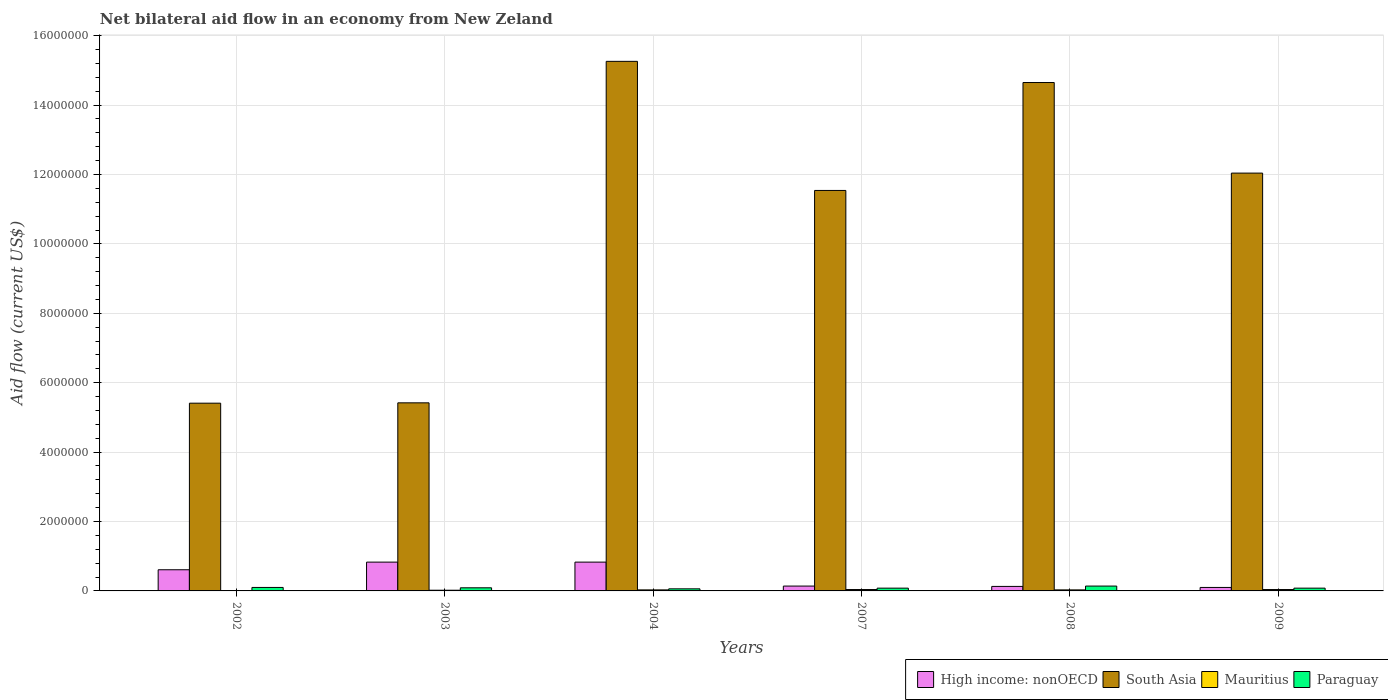How many different coloured bars are there?
Provide a succinct answer. 4. Are the number of bars per tick equal to the number of legend labels?
Offer a terse response. Yes. How many bars are there on the 5th tick from the right?
Keep it short and to the point. 4. What is the label of the 4th group of bars from the left?
Your answer should be very brief. 2007. In how many cases, is the number of bars for a given year not equal to the number of legend labels?
Offer a terse response. 0. In which year was the net bilateral aid flow in Paraguay minimum?
Give a very brief answer. 2004. What is the total net bilateral aid flow in South Asia in the graph?
Offer a terse response. 6.43e+07. What is the difference between the net bilateral aid flow in South Asia in 2002 and that in 2008?
Your answer should be compact. -9.24e+06. What is the average net bilateral aid flow in Mauritius per year?
Provide a succinct answer. 2.83e+04. In the year 2007, what is the difference between the net bilateral aid flow in High income: nonOECD and net bilateral aid flow in South Asia?
Make the answer very short. -1.14e+07. In how many years, is the net bilateral aid flow in Mauritius greater than 14400000 US$?
Your answer should be very brief. 0. What is the ratio of the net bilateral aid flow in South Asia in 2003 to that in 2004?
Your answer should be compact. 0.36. Is the net bilateral aid flow in South Asia in 2002 less than that in 2004?
Provide a succinct answer. Yes. What is the difference between the highest and the second highest net bilateral aid flow in High income: nonOECD?
Offer a very short reply. 0. What is the difference between the highest and the lowest net bilateral aid flow in South Asia?
Give a very brief answer. 9.85e+06. In how many years, is the net bilateral aid flow in South Asia greater than the average net bilateral aid flow in South Asia taken over all years?
Offer a terse response. 4. Is it the case that in every year, the sum of the net bilateral aid flow in South Asia and net bilateral aid flow in High income: nonOECD is greater than the sum of net bilateral aid flow in Paraguay and net bilateral aid flow in Mauritius?
Make the answer very short. No. What does the 2nd bar from the left in 2004 represents?
Provide a short and direct response. South Asia. What does the 3rd bar from the right in 2003 represents?
Make the answer very short. South Asia. How many bars are there?
Offer a terse response. 24. How many years are there in the graph?
Provide a short and direct response. 6. What is the difference between two consecutive major ticks on the Y-axis?
Provide a succinct answer. 2.00e+06. Where does the legend appear in the graph?
Your answer should be compact. Bottom right. How are the legend labels stacked?
Offer a very short reply. Horizontal. What is the title of the graph?
Provide a short and direct response. Net bilateral aid flow in an economy from New Zeland. What is the Aid flow (current US$) of High income: nonOECD in 2002?
Offer a very short reply. 6.10e+05. What is the Aid flow (current US$) of South Asia in 2002?
Your response must be concise. 5.41e+06. What is the Aid flow (current US$) of High income: nonOECD in 2003?
Your response must be concise. 8.30e+05. What is the Aid flow (current US$) in South Asia in 2003?
Ensure brevity in your answer.  5.42e+06. What is the Aid flow (current US$) of Paraguay in 2003?
Ensure brevity in your answer.  9.00e+04. What is the Aid flow (current US$) of High income: nonOECD in 2004?
Provide a short and direct response. 8.30e+05. What is the Aid flow (current US$) in South Asia in 2004?
Your answer should be compact. 1.53e+07. What is the Aid flow (current US$) of South Asia in 2007?
Ensure brevity in your answer.  1.15e+07. What is the Aid flow (current US$) in Mauritius in 2007?
Give a very brief answer. 4.00e+04. What is the Aid flow (current US$) of Paraguay in 2007?
Provide a short and direct response. 8.00e+04. What is the Aid flow (current US$) of South Asia in 2008?
Your answer should be compact. 1.46e+07. What is the Aid flow (current US$) of Paraguay in 2008?
Make the answer very short. 1.40e+05. What is the Aid flow (current US$) in South Asia in 2009?
Provide a succinct answer. 1.20e+07. Across all years, what is the maximum Aid flow (current US$) of High income: nonOECD?
Keep it short and to the point. 8.30e+05. Across all years, what is the maximum Aid flow (current US$) in South Asia?
Ensure brevity in your answer.  1.53e+07. Across all years, what is the maximum Aid flow (current US$) of Mauritius?
Your answer should be compact. 4.00e+04. Across all years, what is the maximum Aid flow (current US$) in Paraguay?
Give a very brief answer. 1.40e+05. Across all years, what is the minimum Aid flow (current US$) in High income: nonOECD?
Offer a terse response. 1.00e+05. Across all years, what is the minimum Aid flow (current US$) in South Asia?
Keep it short and to the point. 5.41e+06. What is the total Aid flow (current US$) in High income: nonOECD in the graph?
Make the answer very short. 2.64e+06. What is the total Aid flow (current US$) in South Asia in the graph?
Your response must be concise. 6.43e+07. What is the total Aid flow (current US$) in Paraguay in the graph?
Your answer should be very brief. 5.50e+05. What is the difference between the Aid flow (current US$) of High income: nonOECD in 2002 and that in 2004?
Offer a terse response. -2.20e+05. What is the difference between the Aid flow (current US$) of South Asia in 2002 and that in 2004?
Ensure brevity in your answer.  -9.85e+06. What is the difference between the Aid flow (current US$) of Paraguay in 2002 and that in 2004?
Offer a terse response. 4.00e+04. What is the difference between the Aid flow (current US$) in South Asia in 2002 and that in 2007?
Keep it short and to the point. -6.13e+06. What is the difference between the Aid flow (current US$) of Paraguay in 2002 and that in 2007?
Your answer should be very brief. 2.00e+04. What is the difference between the Aid flow (current US$) of High income: nonOECD in 2002 and that in 2008?
Your response must be concise. 4.80e+05. What is the difference between the Aid flow (current US$) in South Asia in 2002 and that in 2008?
Keep it short and to the point. -9.24e+06. What is the difference between the Aid flow (current US$) in Paraguay in 2002 and that in 2008?
Make the answer very short. -4.00e+04. What is the difference between the Aid flow (current US$) of High income: nonOECD in 2002 and that in 2009?
Give a very brief answer. 5.10e+05. What is the difference between the Aid flow (current US$) of South Asia in 2002 and that in 2009?
Keep it short and to the point. -6.63e+06. What is the difference between the Aid flow (current US$) in Mauritius in 2002 and that in 2009?
Provide a short and direct response. -3.00e+04. What is the difference between the Aid flow (current US$) of South Asia in 2003 and that in 2004?
Your answer should be very brief. -9.84e+06. What is the difference between the Aid flow (current US$) in High income: nonOECD in 2003 and that in 2007?
Give a very brief answer. 6.90e+05. What is the difference between the Aid flow (current US$) in South Asia in 2003 and that in 2007?
Provide a succinct answer. -6.12e+06. What is the difference between the Aid flow (current US$) in High income: nonOECD in 2003 and that in 2008?
Ensure brevity in your answer.  7.00e+05. What is the difference between the Aid flow (current US$) in South Asia in 2003 and that in 2008?
Offer a terse response. -9.23e+06. What is the difference between the Aid flow (current US$) of Mauritius in 2003 and that in 2008?
Make the answer very short. -10000. What is the difference between the Aid flow (current US$) of High income: nonOECD in 2003 and that in 2009?
Provide a short and direct response. 7.30e+05. What is the difference between the Aid flow (current US$) of South Asia in 2003 and that in 2009?
Give a very brief answer. -6.62e+06. What is the difference between the Aid flow (current US$) of Paraguay in 2003 and that in 2009?
Offer a terse response. 10000. What is the difference between the Aid flow (current US$) in High income: nonOECD in 2004 and that in 2007?
Offer a very short reply. 6.90e+05. What is the difference between the Aid flow (current US$) in South Asia in 2004 and that in 2007?
Give a very brief answer. 3.72e+06. What is the difference between the Aid flow (current US$) of South Asia in 2004 and that in 2008?
Offer a terse response. 6.10e+05. What is the difference between the Aid flow (current US$) in Paraguay in 2004 and that in 2008?
Offer a terse response. -8.00e+04. What is the difference between the Aid flow (current US$) in High income: nonOECD in 2004 and that in 2009?
Give a very brief answer. 7.30e+05. What is the difference between the Aid flow (current US$) in South Asia in 2004 and that in 2009?
Provide a short and direct response. 3.22e+06. What is the difference between the Aid flow (current US$) in Paraguay in 2004 and that in 2009?
Provide a succinct answer. -2.00e+04. What is the difference between the Aid flow (current US$) of South Asia in 2007 and that in 2008?
Make the answer very short. -3.11e+06. What is the difference between the Aid flow (current US$) of Mauritius in 2007 and that in 2008?
Your answer should be compact. 10000. What is the difference between the Aid flow (current US$) in High income: nonOECD in 2007 and that in 2009?
Give a very brief answer. 4.00e+04. What is the difference between the Aid flow (current US$) of South Asia in 2007 and that in 2009?
Offer a terse response. -5.00e+05. What is the difference between the Aid flow (current US$) in Paraguay in 2007 and that in 2009?
Your answer should be compact. 0. What is the difference between the Aid flow (current US$) of High income: nonOECD in 2008 and that in 2009?
Provide a short and direct response. 3.00e+04. What is the difference between the Aid flow (current US$) of South Asia in 2008 and that in 2009?
Give a very brief answer. 2.61e+06. What is the difference between the Aid flow (current US$) in Paraguay in 2008 and that in 2009?
Keep it short and to the point. 6.00e+04. What is the difference between the Aid flow (current US$) of High income: nonOECD in 2002 and the Aid flow (current US$) of South Asia in 2003?
Give a very brief answer. -4.81e+06. What is the difference between the Aid flow (current US$) of High income: nonOECD in 2002 and the Aid flow (current US$) of Mauritius in 2003?
Keep it short and to the point. 5.90e+05. What is the difference between the Aid flow (current US$) in High income: nonOECD in 2002 and the Aid flow (current US$) in Paraguay in 2003?
Offer a very short reply. 5.20e+05. What is the difference between the Aid flow (current US$) in South Asia in 2002 and the Aid flow (current US$) in Mauritius in 2003?
Offer a terse response. 5.39e+06. What is the difference between the Aid flow (current US$) in South Asia in 2002 and the Aid flow (current US$) in Paraguay in 2003?
Offer a terse response. 5.32e+06. What is the difference between the Aid flow (current US$) of High income: nonOECD in 2002 and the Aid flow (current US$) of South Asia in 2004?
Your answer should be very brief. -1.46e+07. What is the difference between the Aid flow (current US$) of High income: nonOECD in 2002 and the Aid flow (current US$) of Mauritius in 2004?
Your answer should be very brief. 5.80e+05. What is the difference between the Aid flow (current US$) in High income: nonOECD in 2002 and the Aid flow (current US$) in Paraguay in 2004?
Make the answer very short. 5.50e+05. What is the difference between the Aid flow (current US$) in South Asia in 2002 and the Aid flow (current US$) in Mauritius in 2004?
Your answer should be very brief. 5.38e+06. What is the difference between the Aid flow (current US$) of South Asia in 2002 and the Aid flow (current US$) of Paraguay in 2004?
Provide a succinct answer. 5.35e+06. What is the difference between the Aid flow (current US$) of High income: nonOECD in 2002 and the Aid flow (current US$) of South Asia in 2007?
Offer a terse response. -1.09e+07. What is the difference between the Aid flow (current US$) of High income: nonOECD in 2002 and the Aid flow (current US$) of Mauritius in 2007?
Provide a short and direct response. 5.70e+05. What is the difference between the Aid flow (current US$) in High income: nonOECD in 2002 and the Aid flow (current US$) in Paraguay in 2007?
Keep it short and to the point. 5.30e+05. What is the difference between the Aid flow (current US$) in South Asia in 2002 and the Aid flow (current US$) in Mauritius in 2007?
Give a very brief answer. 5.37e+06. What is the difference between the Aid flow (current US$) of South Asia in 2002 and the Aid flow (current US$) of Paraguay in 2007?
Ensure brevity in your answer.  5.33e+06. What is the difference between the Aid flow (current US$) of Mauritius in 2002 and the Aid flow (current US$) of Paraguay in 2007?
Your answer should be compact. -7.00e+04. What is the difference between the Aid flow (current US$) in High income: nonOECD in 2002 and the Aid flow (current US$) in South Asia in 2008?
Offer a very short reply. -1.40e+07. What is the difference between the Aid flow (current US$) of High income: nonOECD in 2002 and the Aid flow (current US$) of Mauritius in 2008?
Your response must be concise. 5.80e+05. What is the difference between the Aid flow (current US$) of South Asia in 2002 and the Aid flow (current US$) of Mauritius in 2008?
Your answer should be compact. 5.38e+06. What is the difference between the Aid flow (current US$) of South Asia in 2002 and the Aid flow (current US$) of Paraguay in 2008?
Your answer should be compact. 5.27e+06. What is the difference between the Aid flow (current US$) in Mauritius in 2002 and the Aid flow (current US$) in Paraguay in 2008?
Make the answer very short. -1.30e+05. What is the difference between the Aid flow (current US$) of High income: nonOECD in 2002 and the Aid flow (current US$) of South Asia in 2009?
Keep it short and to the point. -1.14e+07. What is the difference between the Aid flow (current US$) in High income: nonOECD in 2002 and the Aid flow (current US$) in Mauritius in 2009?
Your answer should be compact. 5.70e+05. What is the difference between the Aid flow (current US$) in High income: nonOECD in 2002 and the Aid flow (current US$) in Paraguay in 2009?
Offer a terse response. 5.30e+05. What is the difference between the Aid flow (current US$) of South Asia in 2002 and the Aid flow (current US$) of Mauritius in 2009?
Your answer should be very brief. 5.37e+06. What is the difference between the Aid flow (current US$) of South Asia in 2002 and the Aid flow (current US$) of Paraguay in 2009?
Your answer should be compact. 5.33e+06. What is the difference between the Aid flow (current US$) of High income: nonOECD in 2003 and the Aid flow (current US$) of South Asia in 2004?
Offer a very short reply. -1.44e+07. What is the difference between the Aid flow (current US$) of High income: nonOECD in 2003 and the Aid flow (current US$) of Paraguay in 2004?
Keep it short and to the point. 7.70e+05. What is the difference between the Aid flow (current US$) in South Asia in 2003 and the Aid flow (current US$) in Mauritius in 2004?
Offer a terse response. 5.39e+06. What is the difference between the Aid flow (current US$) of South Asia in 2003 and the Aid flow (current US$) of Paraguay in 2004?
Ensure brevity in your answer.  5.36e+06. What is the difference between the Aid flow (current US$) in Mauritius in 2003 and the Aid flow (current US$) in Paraguay in 2004?
Offer a terse response. -4.00e+04. What is the difference between the Aid flow (current US$) of High income: nonOECD in 2003 and the Aid flow (current US$) of South Asia in 2007?
Offer a terse response. -1.07e+07. What is the difference between the Aid flow (current US$) of High income: nonOECD in 2003 and the Aid flow (current US$) of Mauritius in 2007?
Offer a terse response. 7.90e+05. What is the difference between the Aid flow (current US$) in High income: nonOECD in 2003 and the Aid flow (current US$) in Paraguay in 2007?
Keep it short and to the point. 7.50e+05. What is the difference between the Aid flow (current US$) of South Asia in 2003 and the Aid flow (current US$) of Mauritius in 2007?
Your response must be concise. 5.38e+06. What is the difference between the Aid flow (current US$) of South Asia in 2003 and the Aid flow (current US$) of Paraguay in 2007?
Ensure brevity in your answer.  5.34e+06. What is the difference between the Aid flow (current US$) of Mauritius in 2003 and the Aid flow (current US$) of Paraguay in 2007?
Provide a short and direct response. -6.00e+04. What is the difference between the Aid flow (current US$) of High income: nonOECD in 2003 and the Aid flow (current US$) of South Asia in 2008?
Keep it short and to the point. -1.38e+07. What is the difference between the Aid flow (current US$) of High income: nonOECD in 2003 and the Aid flow (current US$) of Mauritius in 2008?
Your answer should be very brief. 8.00e+05. What is the difference between the Aid flow (current US$) of High income: nonOECD in 2003 and the Aid flow (current US$) of Paraguay in 2008?
Provide a short and direct response. 6.90e+05. What is the difference between the Aid flow (current US$) of South Asia in 2003 and the Aid flow (current US$) of Mauritius in 2008?
Give a very brief answer. 5.39e+06. What is the difference between the Aid flow (current US$) in South Asia in 2003 and the Aid flow (current US$) in Paraguay in 2008?
Give a very brief answer. 5.28e+06. What is the difference between the Aid flow (current US$) in Mauritius in 2003 and the Aid flow (current US$) in Paraguay in 2008?
Provide a succinct answer. -1.20e+05. What is the difference between the Aid flow (current US$) in High income: nonOECD in 2003 and the Aid flow (current US$) in South Asia in 2009?
Give a very brief answer. -1.12e+07. What is the difference between the Aid flow (current US$) in High income: nonOECD in 2003 and the Aid flow (current US$) in Mauritius in 2009?
Provide a short and direct response. 7.90e+05. What is the difference between the Aid flow (current US$) in High income: nonOECD in 2003 and the Aid flow (current US$) in Paraguay in 2009?
Give a very brief answer. 7.50e+05. What is the difference between the Aid flow (current US$) of South Asia in 2003 and the Aid flow (current US$) of Mauritius in 2009?
Make the answer very short. 5.38e+06. What is the difference between the Aid flow (current US$) of South Asia in 2003 and the Aid flow (current US$) of Paraguay in 2009?
Your answer should be compact. 5.34e+06. What is the difference between the Aid flow (current US$) of Mauritius in 2003 and the Aid flow (current US$) of Paraguay in 2009?
Offer a very short reply. -6.00e+04. What is the difference between the Aid flow (current US$) of High income: nonOECD in 2004 and the Aid flow (current US$) of South Asia in 2007?
Offer a terse response. -1.07e+07. What is the difference between the Aid flow (current US$) of High income: nonOECD in 2004 and the Aid flow (current US$) of Mauritius in 2007?
Your answer should be very brief. 7.90e+05. What is the difference between the Aid flow (current US$) in High income: nonOECD in 2004 and the Aid flow (current US$) in Paraguay in 2007?
Provide a succinct answer. 7.50e+05. What is the difference between the Aid flow (current US$) in South Asia in 2004 and the Aid flow (current US$) in Mauritius in 2007?
Provide a succinct answer. 1.52e+07. What is the difference between the Aid flow (current US$) of South Asia in 2004 and the Aid flow (current US$) of Paraguay in 2007?
Provide a short and direct response. 1.52e+07. What is the difference between the Aid flow (current US$) in Mauritius in 2004 and the Aid flow (current US$) in Paraguay in 2007?
Your answer should be very brief. -5.00e+04. What is the difference between the Aid flow (current US$) of High income: nonOECD in 2004 and the Aid flow (current US$) of South Asia in 2008?
Offer a very short reply. -1.38e+07. What is the difference between the Aid flow (current US$) of High income: nonOECD in 2004 and the Aid flow (current US$) of Paraguay in 2008?
Provide a short and direct response. 6.90e+05. What is the difference between the Aid flow (current US$) of South Asia in 2004 and the Aid flow (current US$) of Mauritius in 2008?
Provide a short and direct response. 1.52e+07. What is the difference between the Aid flow (current US$) of South Asia in 2004 and the Aid flow (current US$) of Paraguay in 2008?
Make the answer very short. 1.51e+07. What is the difference between the Aid flow (current US$) in Mauritius in 2004 and the Aid flow (current US$) in Paraguay in 2008?
Provide a succinct answer. -1.10e+05. What is the difference between the Aid flow (current US$) of High income: nonOECD in 2004 and the Aid flow (current US$) of South Asia in 2009?
Make the answer very short. -1.12e+07. What is the difference between the Aid flow (current US$) in High income: nonOECD in 2004 and the Aid flow (current US$) in Mauritius in 2009?
Offer a terse response. 7.90e+05. What is the difference between the Aid flow (current US$) in High income: nonOECD in 2004 and the Aid flow (current US$) in Paraguay in 2009?
Your answer should be very brief. 7.50e+05. What is the difference between the Aid flow (current US$) of South Asia in 2004 and the Aid flow (current US$) of Mauritius in 2009?
Your answer should be very brief. 1.52e+07. What is the difference between the Aid flow (current US$) of South Asia in 2004 and the Aid flow (current US$) of Paraguay in 2009?
Offer a terse response. 1.52e+07. What is the difference between the Aid flow (current US$) of Mauritius in 2004 and the Aid flow (current US$) of Paraguay in 2009?
Ensure brevity in your answer.  -5.00e+04. What is the difference between the Aid flow (current US$) in High income: nonOECD in 2007 and the Aid flow (current US$) in South Asia in 2008?
Make the answer very short. -1.45e+07. What is the difference between the Aid flow (current US$) of High income: nonOECD in 2007 and the Aid flow (current US$) of Mauritius in 2008?
Give a very brief answer. 1.10e+05. What is the difference between the Aid flow (current US$) of High income: nonOECD in 2007 and the Aid flow (current US$) of Paraguay in 2008?
Keep it short and to the point. 0. What is the difference between the Aid flow (current US$) of South Asia in 2007 and the Aid flow (current US$) of Mauritius in 2008?
Offer a terse response. 1.15e+07. What is the difference between the Aid flow (current US$) in South Asia in 2007 and the Aid flow (current US$) in Paraguay in 2008?
Offer a very short reply. 1.14e+07. What is the difference between the Aid flow (current US$) in Mauritius in 2007 and the Aid flow (current US$) in Paraguay in 2008?
Offer a very short reply. -1.00e+05. What is the difference between the Aid flow (current US$) of High income: nonOECD in 2007 and the Aid flow (current US$) of South Asia in 2009?
Your answer should be very brief. -1.19e+07. What is the difference between the Aid flow (current US$) in High income: nonOECD in 2007 and the Aid flow (current US$) in Mauritius in 2009?
Provide a succinct answer. 1.00e+05. What is the difference between the Aid flow (current US$) in High income: nonOECD in 2007 and the Aid flow (current US$) in Paraguay in 2009?
Offer a terse response. 6.00e+04. What is the difference between the Aid flow (current US$) of South Asia in 2007 and the Aid flow (current US$) of Mauritius in 2009?
Keep it short and to the point. 1.15e+07. What is the difference between the Aid flow (current US$) in South Asia in 2007 and the Aid flow (current US$) in Paraguay in 2009?
Your answer should be very brief. 1.15e+07. What is the difference between the Aid flow (current US$) of Mauritius in 2007 and the Aid flow (current US$) of Paraguay in 2009?
Make the answer very short. -4.00e+04. What is the difference between the Aid flow (current US$) in High income: nonOECD in 2008 and the Aid flow (current US$) in South Asia in 2009?
Keep it short and to the point. -1.19e+07. What is the difference between the Aid flow (current US$) of High income: nonOECD in 2008 and the Aid flow (current US$) of Paraguay in 2009?
Give a very brief answer. 5.00e+04. What is the difference between the Aid flow (current US$) of South Asia in 2008 and the Aid flow (current US$) of Mauritius in 2009?
Give a very brief answer. 1.46e+07. What is the difference between the Aid flow (current US$) in South Asia in 2008 and the Aid flow (current US$) in Paraguay in 2009?
Make the answer very short. 1.46e+07. What is the average Aid flow (current US$) in South Asia per year?
Your answer should be compact. 1.07e+07. What is the average Aid flow (current US$) in Mauritius per year?
Make the answer very short. 2.83e+04. What is the average Aid flow (current US$) of Paraguay per year?
Your answer should be compact. 9.17e+04. In the year 2002, what is the difference between the Aid flow (current US$) in High income: nonOECD and Aid flow (current US$) in South Asia?
Provide a succinct answer. -4.80e+06. In the year 2002, what is the difference between the Aid flow (current US$) of High income: nonOECD and Aid flow (current US$) of Paraguay?
Offer a very short reply. 5.10e+05. In the year 2002, what is the difference between the Aid flow (current US$) in South Asia and Aid flow (current US$) in Mauritius?
Make the answer very short. 5.40e+06. In the year 2002, what is the difference between the Aid flow (current US$) of South Asia and Aid flow (current US$) of Paraguay?
Offer a very short reply. 5.31e+06. In the year 2003, what is the difference between the Aid flow (current US$) in High income: nonOECD and Aid flow (current US$) in South Asia?
Keep it short and to the point. -4.59e+06. In the year 2003, what is the difference between the Aid flow (current US$) of High income: nonOECD and Aid flow (current US$) of Mauritius?
Provide a short and direct response. 8.10e+05. In the year 2003, what is the difference between the Aid flow (current US$) of High income: nonOECD and Aid flow (current US$) of Paraguay?
Make the answer very short. 7.40e+05. In the year 2003, what is the difference between the Aid flow (current US$) of South Asia and Aid flow (current US$) of Mauritius?
Give a very brief answer. 5.40e+06. In the year 2003, what is the difference between the Aid flow (current US$) of South Asia and Aid flow (current US$) of Paraguay?
Offer a terse response. 5.33e+06. In the year 2003, what is the difference between the Aid flow (current US$) of Mauritius and Aid flow (current US$) of Paraguay?
Offer a very short reply. -7.00e+04. In the year 2004, what is the difference between the Aid flow (current US$) of High income: nonOECD and Aid flow (current US$) of South Asia?
Keep it short and to the point. -1.44e+07. In the year 2004, what is the difference between the Aid flow (current US$) in High income: nonOECD and Aid flow (current US$) in Mauritius?
Your answer should be compact. 8.00e+05. In the year 2004, what is the difference between the Aid flow (current US$) of High income: nonOECD and Aid flow (current US$) of Paraguay?
Your answer should be very brief. 7.70e+05. In the year 2004, what is the difference between the Aid flow (current US$) of South Asia and Aid flow (current US$) of Mauritius?
Ensure brevity in your answer.  1.52e+07. In the year 2004, what is the difference between the Aid flow (current US$) of South Asia and Aid flow (current US$) of Paraguay?
Offer a very short reply. 1.52e+07. In the year 2004, what is the difference between the Aid flow (current US$) in Mauritius and Aid flow (current US$) in Paraguay?
Your response must be concise. -3.00e+04. In the year 2007, what is the difference between the Aid flow (current US$) of High income: nonOECD and Aid flow (current US$) of South Asia?
Ensure brevity in your answer.  -1.14e+07. In the year 2007, what is the difference between the Aid flow (current US$) in High income: nonOECD and Aid flow (current US$) in Mauritius?
Your answer should be compact. 1.00e+05. In the year 2007, what is the difference between the Aid flow (current US$) in High income: nonOECD and Aid flow (current US$) in Paraguay?
Give a very brief answer. 6.00e+04. In the year 2007, what is the difference between the Aid flow (current US$) of South Asia and Aid flow (current US$) of Mauritius?
Give a very brief answer. 1.15e+07. In the year 2007, what is the difference between the Aid flow (current US$) in South Asia and Aid flow (current US$) in Paraguay?
Give a very brief answer. 1.15e+07. In the year 2007, what is the difference between the Aid flow (current US$) of Mauritius and Aid flow (current US$) of Paraguay?
Your answer should be very brief. -4.00e+04. In the year 2008, what is the difference between the Aid flow (current US$) of High income: nonOECD and Aid flow (current US$) of South Asia?
Ensure brevity in your answer.  -1.45e+07. In the year 2008, what is the difference between the Aid flow (current US$) of High income: nonOECD and Aid flow (current US$) of Paraguay?
Keep it short and to the point. -10000. In the year 2008, what is the difference between the Aid flow (current US$) in South Asia and Aid flow (current US$) in Mauritius?
Ensure brevity in your answer.  1.46e+07. In the year 2008, what is the difference between the Aid flow (current US$) in South Asia and Aid flow (current US$) in Paraguay?
Give a very brief answer. 1.45e+07. In the year 2009, what is the difference between the Aid flow (current US$) in High income: nonOECD and Aid flow (current US$) in South Asia?
Offer a very short reply. -1.19e+07. In the year 2009, what is the difference between the Aid flow (current US$) in High income: nonOECD and Aid flow (current US$) in Mauritius?
Provide a succinct answer. 6.00e+04. In the year 2009, what is the difference between the Aid flow (current US$) in High income: nonOECD and Aid flow (current US$) in Paraguay?
Your answer should be compact. 2.00e+04. In the year 2009, what is the difference between the Aid flow (current US$) in South Asia and Aid flow (current US$) in Mauritius?
Ensure brevity in your answer.  1.20e+07. In the year 2009, what is the difference between the Aid flow (current US$) in South Asia and Aid flow (current US$) in Paraguay?
Give a very brief answer. 1.20e+07. What is the ratio of the Aid flow (current US$) in High income: nonOECD in 2002 to that in 2003?
Make the answer very short. 0.73. What is the ratio of the Aid flow (current US$) in South Asia in 2002 to that in 2003?
Your response must be concise. 1. What is the ratio of the Aid flow (current US$) in Mauritius in 2002 to that in 2003?
Give a very brief answer. 0.5. What is the ratio of the Aid flow (current US$) of High income: nonOECD in 2002 to that in 2004?
Offer a very short reply. 0.73. What is the ratio of the Aid flow (current US$) of South Asia in 2002 to that in 2004?
Make the answer very short. 0.35. What is the ratio of the Aid flow (current US$) of Mauritius in 2002 to that in 2004?
Your answer should be very brief. 0.33. What is the ratio of the Aid flow (current US$) of Paraguay in 2002 to that in 2004?
Give a very brief answer. 1.67. What is the ratio of the Aid flow (current US$) of High income: nonOECD in 2002 to that in 2007?
Offer a very short reply. 4.36. What is the ratio of the Aid flow (current US$) of South Asia in 2002 to that in 2007?
Your answer should be very brief. 0.47. What is the ratio of the Aid flow (current US$) in Mauritius in 2002 to that in 2007?
Offer a very short reply. 0.25. What is the ratio of the Aid flow (current US$) of Paraguay in 2002 to that in 2007?
Your response must be concise. 1.25. What is the ratio of the Aid flow (current US$) of High income: nonOECD in 2002 to that in 2008?
Your response must be concise. 4.69. What is the ratio of the Aid flow (current US$) of South Asia in 2002 to that in 2008?
Your answer should be very brief. 0.37. What is the ratio of the Aid flow (current US$) of Mauritius in 2002 to that in 2008?
Your response must be concise. 0.33. What is the ratio of the Aid flow (current US$) of High income: nonOECD in 2002 to that in 2009?
Keep it short and to the point. 6.1. What is the ratio of the Aid flow (current US$) of South Asia in 2002 to that in 2009?
Keep it short and to the point. 0.45. What is the ratio of the Aid flow (current US$) in Mauritius in 2002 to that in 2009?
Keep it short and to the point. 0.25. What is the ratio of the Aid flow (current US$) in South Asia in 2003 to that in 2004?
Offer a terse response. 0.36. What is the ratio of the Aid flow (current US$) in Mauritius in 2003 to that in 2004?
Provide a short and direct response. 0.67. What is the ratio of the Aid flow (current US$) of High income: nonOECD in 2003 to that in 2007?
Give a very brief answer. 5.93. What is the ratio of the Aid flow (current US$) in South Asia in 2003 to that in 2007?
Your answer should be compact. 0.47. What is the ratio of the Aid flow (current US$) in Mauritius in 2003 to that in 2007?
Your response must be concise. 0.5. What is the ratio of the Aid flow (current US$) of High income: nonOECD in 2003 to that in 2008?
Your answer should be compact. 6.38. What is the ratio of the Aid flow (current US$) in South Asia in 2003 to that in 2008?
Give a very brief answer. 0.37. What is the ratio of the Aid flow (current US$) of Mauritius in 2003 to that in 2008?
Provide a short and direct response. 0.67. What is the ratio of the Aid flow (current US$) in Paraguay in 2003 to that in 2008?
Your answer should be very brief. 0.64. What is the ratio of the Aid flow (current US$) of South Asia in 2003 to that in 2009?
Offer a terse response. 0.45. What is the ratio of the Aid flow (current US$) of High income: nonOECD in 2004 to that in 2007?
Ensure brevity in your answer.  5.93. What is the ratio of the Aid flow (current US$) of South Asia in 2004 to that in 2007?
Offer a terse response. 1.32. What is the ratio of the Aid flow (current US$) of Mauritius in 2004 to that in 2007?
Your response must be concise. 0.75. What is the ratio of the Aid flow (current US$) in Paraguay in 2004 to that in 2007?
Provide a short and direct response. 0.75. What is the ratio of the Aid flow (current US$) of High income: nonOECD in 2004 to that in 2008?
Provide a succinct answer. 6.38. What is the ratio of the Aid flow (current US$) of South Asia in 2004 to that in 2008?
Offer a terse response. 1.04. What is the ratio of the Aid flow (current US$) of Paraguay in 2004 to that in 2008?
Your answer should be very brief. 0.43. What is the ratio of the Aid flow (current US$) of South Asia in 2004 to that in 2009?
Your response must be concise. 1.27. What is the ratio of the Aid flow (current US$) of High income: nonOECD in 2007 to that in 2008?
Provide a short and direct response. 1.08. What is the ratio of the Aid flow (current US$) in South Asia in 2007 to that in 2008?
Ensure brevity in your answer.  0.79. What is the ratio of the Aid flow (current US$) of Mauritius in 2007 to that in 2008?
Give a very brief answer. 1.33. What is the ratio of the Aid flow (current US$) in Paraguay in 2007 to that in 2008?
Ensure brevity in your answer.  0.57. What is the ratio of the Aid flow (current US$) of South Asia in 2007 to that in 2009?
Provide a succinct answer. 0.96. What is the ratio of the Aid flow (current US$) in Mauritius in 2007 to that in 2009?
Provide a succinct answer. 1. What is the ratio of the Aid flow (current US$) of Paraguay in 2007 to that in 2009?
Make the answer very short. 1. What is the ratio of the Aid flow (current US$) in South Asia in 2008 to that in 2009?
Your answer should be compact. 1.22. What is the ratio of the Aid flow (current US$) of Mauritius in 2008 to that in 2009?
Provide a short and direct response. 0.75. What is the difference between the highest and the second highest Aid flow (current US$) of South Asia?
Keep it short and to the point. 6.10e+05. What is the difference between the highest and the lowest Aid flow (current US$) of High income: nonOECD?
Make the answer very short. 7.30e+05. What is the difference between the highest and the lowest Aid flow (current US$) in South Asia?
Your response must be concise. 9.85e+06. What is the difference between the highest and the lowest Aid flow (current US$) in Mauritius?
Give a very brief answer. 3.00e+04. 